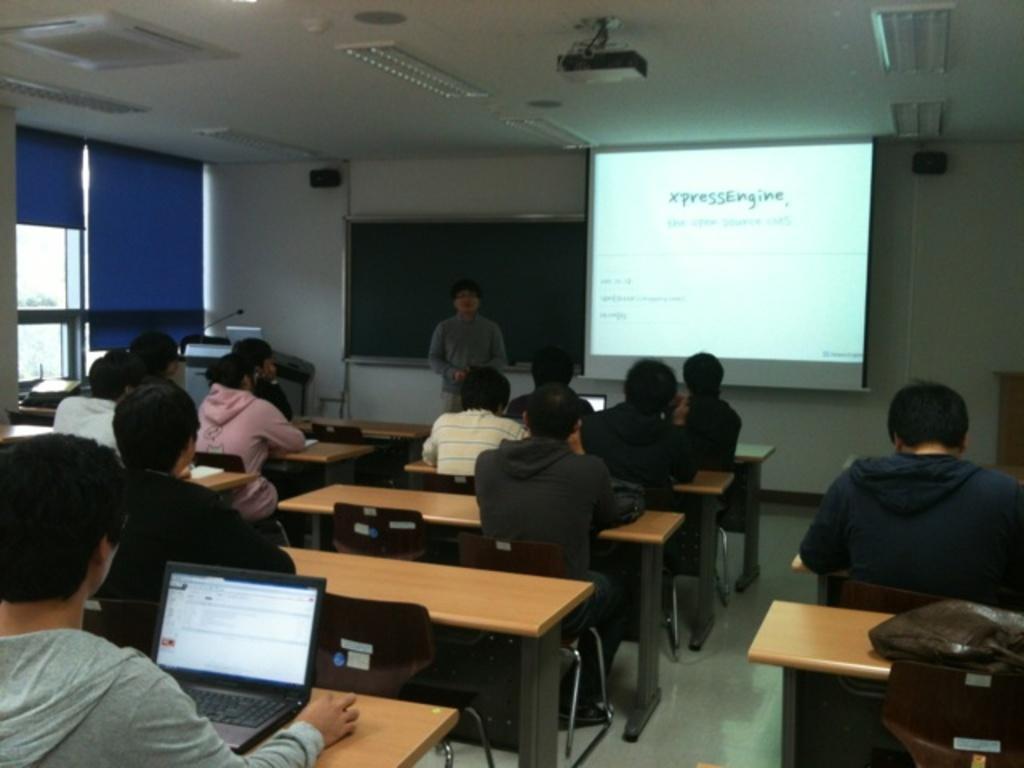In one or two sentences, can you explain what this image depicts? This picture shows a projector screen and projector to the roof and we see people seated on the chairs and we see couple of laptops on the table and we see a man standing and speaking and we see a green board on the back. Picture looks like a classroom and we see a podium with a microphone to it and we see bag on the table. 